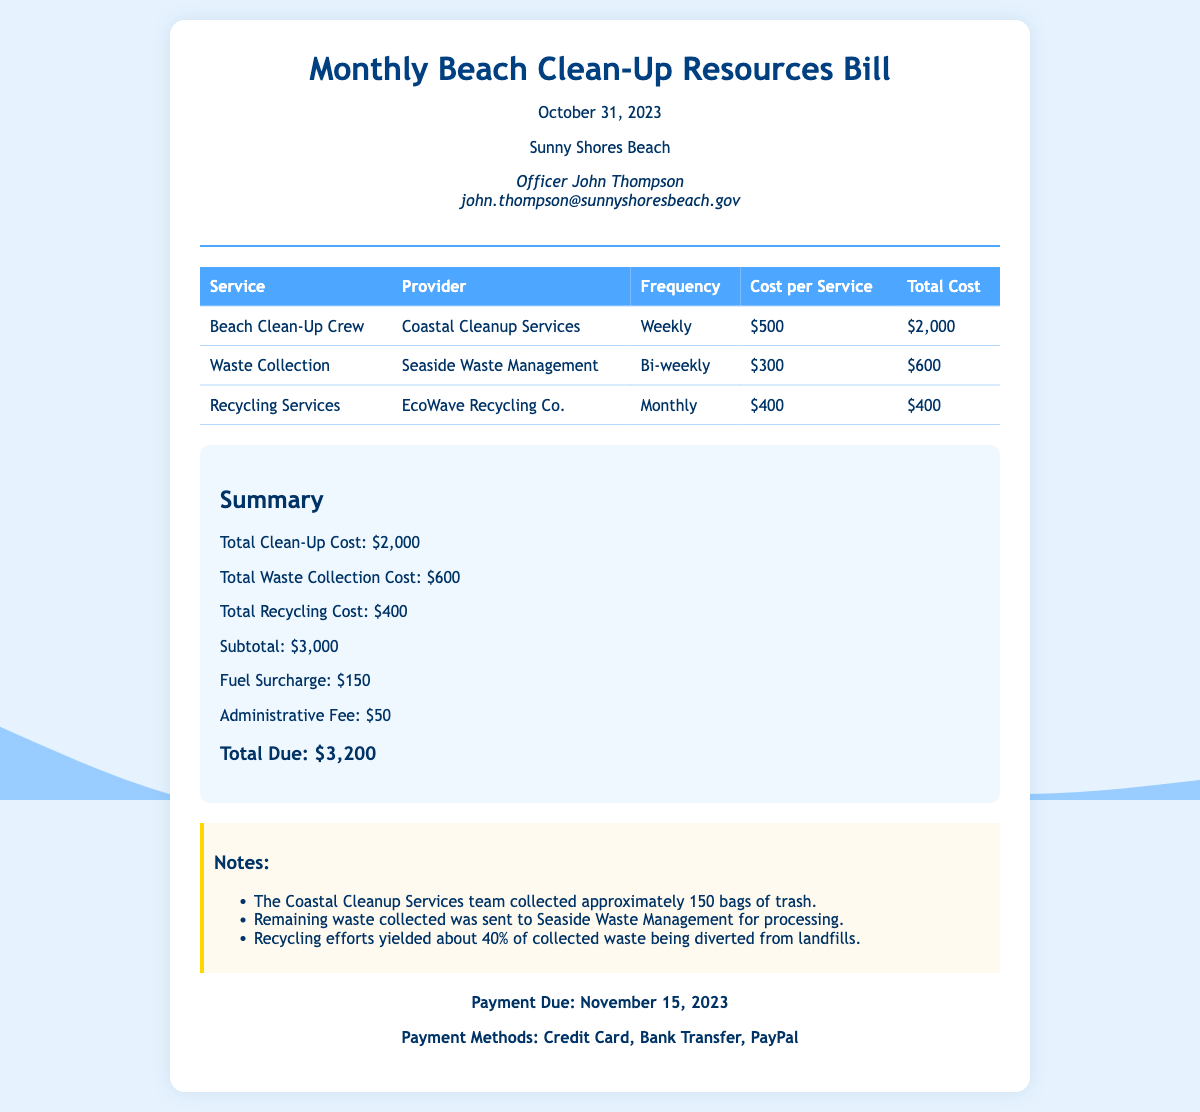What is the name of the beach? The bill mentions the location of the service provided, which is Sunny Shores Beach.
Answer: Sunny Shores Beach Who is the officer in charge? The document specifies the officer overseeing the beach, identifying him as Officer John Thompson.
Answer: Officer John Thompson What is the total cost for waste collection? The total cost for waste collection is provided in the summary section of the document.
Answer: $600 How often does the Beach Clean-Up Crew operate? The frequency of the Beach Clean-Up Crew's service is stated in the services table.
Answer: Weekly What is the date payment is due? The document mentions the due date for the payment as part of the payment information section.
Answer: November 15, 2023 What was the total number of trash bags collected? The document notes the number of bags collected by the Coastal Cleanup Services team in the notes section.
Answer: 150 How much was charged as an administrative fee? The administrative fee is listed in the summary breakdown of additional charges.
Answer: $50 What percentage of waste was diverted from landfills? The notes section specifies the percentage of collected waste that was recycled and diverted from landfills.
Answer: 40% What is the provider for recycling services? The recycling service provider's name is given in the services table of the document.
Answer: EcoWave Recycling Co 